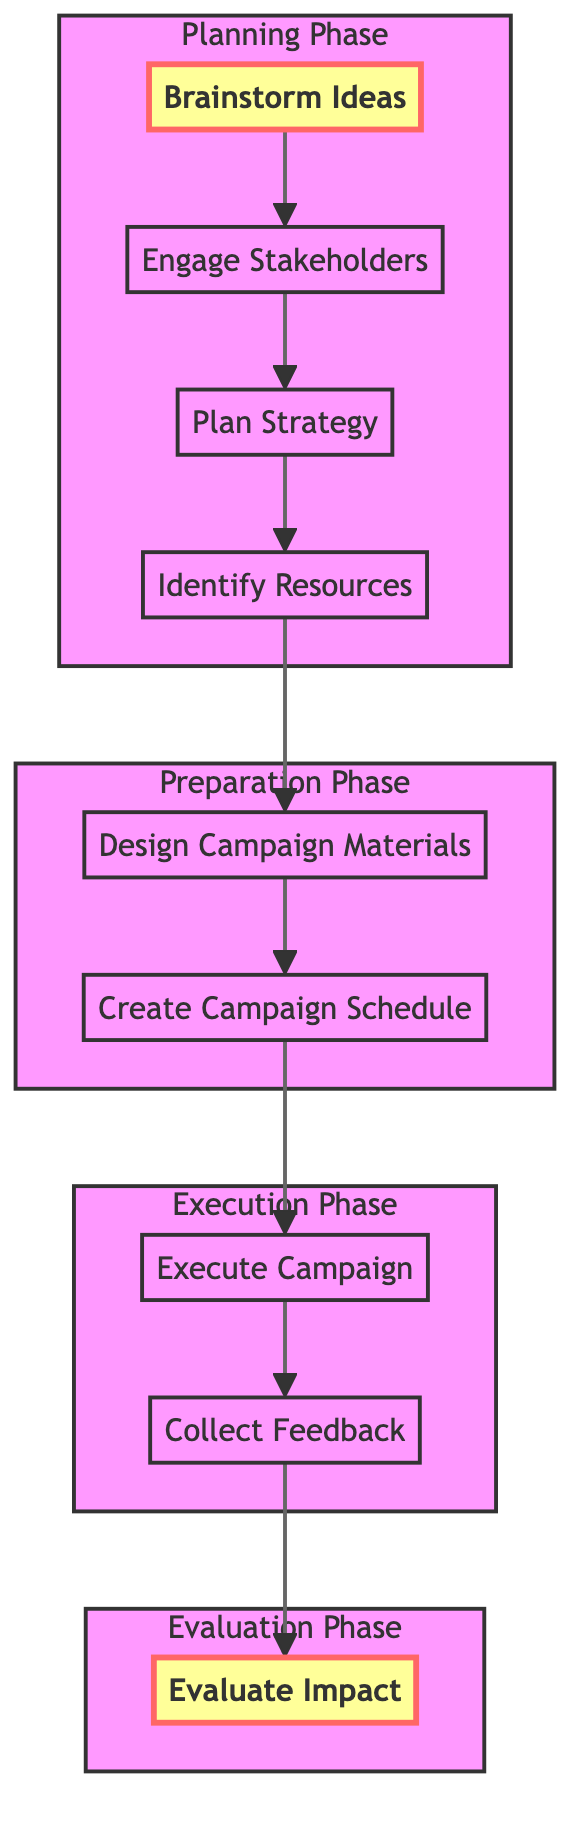What is the first step in the campaign planning? The first step is "Brainstorm Ideas," which is indicated at the bottom of the flowchart.
Answer: Brainstorm Ideas How many phases are there in the advocacy campaign planning process? There are four phases shown in the diagram: Planning Phase, Preparation Phase, Execution Phase, and Evaluation Phase.
Answer: Four What node follows "Engage Stakeholders"? The node that follows "Engage Stakeholders" is "Plan Strategy," connected by the arrow.
Answer: Plan Strategy What is the last step after collecting feedback? The last step after "Collect Feedback" is "Evaluate Impact," which the diagram shows as the terminal node.
Answer: Evaluate Impact Which phase includes "Design Campaign Materials"? "Design Campaign Materials" is part of the Preparation Phase, which also includes "Create Campaign Schedule."
Answer: Preparation Phase To reach "Evaluate Impact," which node must be completed just before it? "Collect Feedback" must be completed just before reaching "Evaluate Impact," based on the flow from the execution phase.
Answer: Collect Feedback Which node represents the step of developing promotional materials? The node representing the step of developing promotional materials is "Design Campaign Materials."
Answer: Design Campaign Materials What is the relationship between "Plan Strategy" and "Identify Resources"? "Plan Strategy" leads to "Identify Resources," indicating that planning the strategy is a prerequisite for identifying necessary resources.
Answer: Leads to What do the highlighted nodes represent in the flowchart? The highlighted nodes represent the beginning and end points of the campaign planning process, starting with "Brainstorm Ideas" and ending with "Evaluate Impact."
Answer: Beginning and end points 